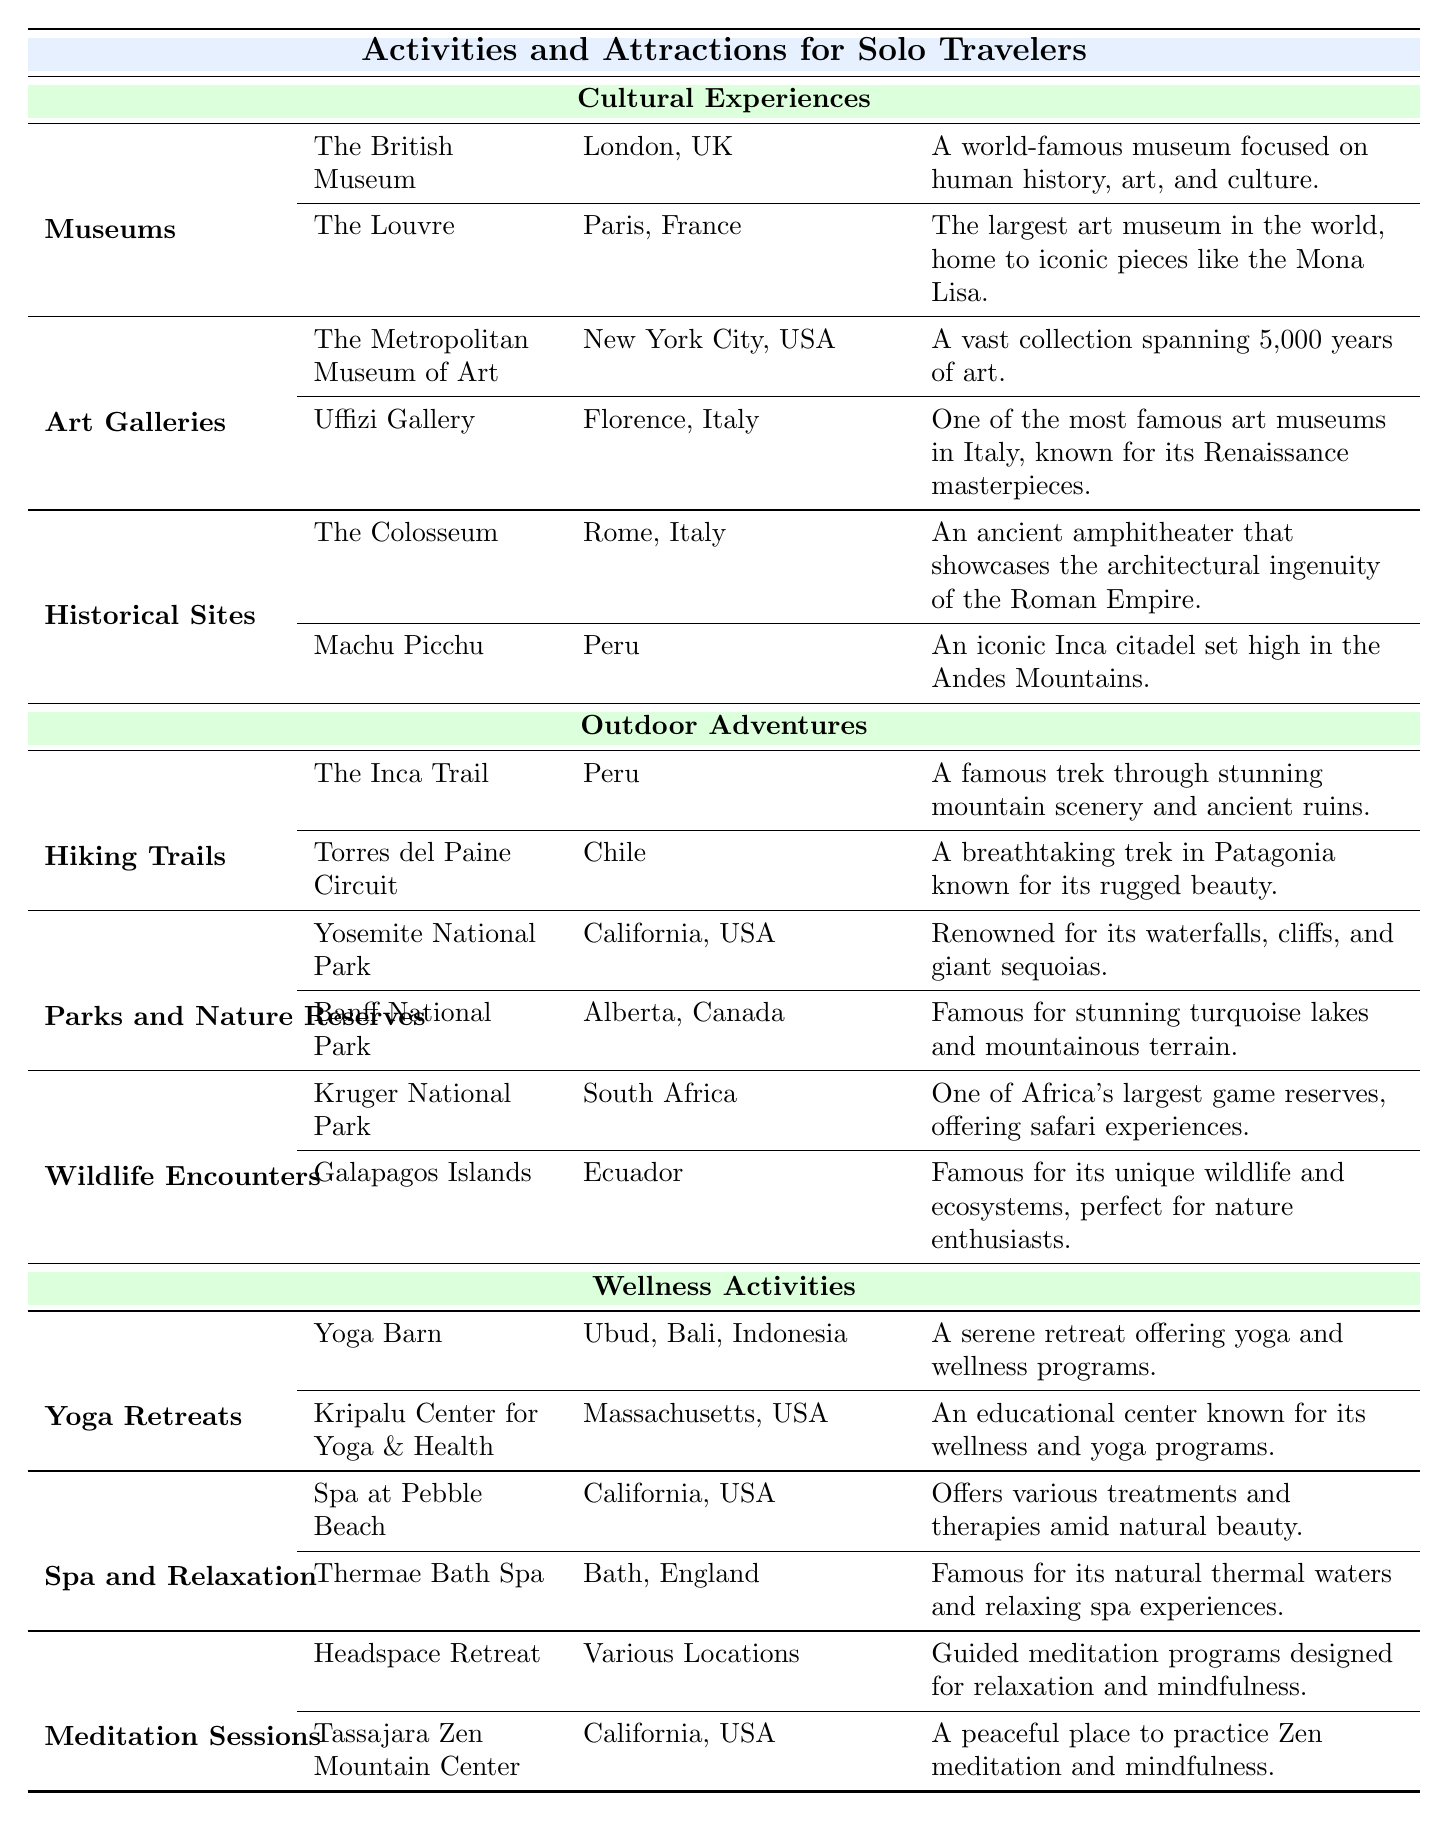What are two museums listed under Cultural Experiences? From the table, under Cultural Experiences, specifically the Museums section, two examples are given: The British Museum located in London, UK, and The Louvre located in Paris, France.
Answer: The British Museum, The Louvre Which country is home to the Galapagos Islands? Looking at the Wildlife Encounters section, the Galapagos Islands are listed with their location noted as Ecuador.
Answer: Ecuador Is the Thermae Bath Spa located in the USA? The table indicates that the Thermae Bath Spa is located in Bath, England, not in the USA, making the statement false.
Answer: No What is the description of the Yoga Barn? The entry for Yoga Barn in the Yoga Retreats section describes it as "A serene retreat offering yoga and wellness programs." This is directly gathered from the description provided in the table.
Answer: A serene retreat offering yoga and wellness programs Which has more outdoor adventure options, Hiking Trails or Parks and Nature Reserves? The Hiking Trails section lists two hiking trails, while the Parks and Nature Reserves section also lists two parks. Since both have the same number of entries, they are equal.
Answer: They have the same number of options What are the two locations for Wellness Activities? From the table, we see three types of wellness activities. The locations include: Ubud, Bali, Indonesia for Yoga Barn and Massachusetts, USA for Kripalu Center for Yoga & Health under Yoga Retreats. The same method applies for Spa and Relaxation in California, USA and Bath, England. So, two locations can be California and Bath.
Answer: California, Bath What type of outdoor adventure can you experience in Patagonia? The Torres del Paine Circuit listed under Hiking Trails in the Outdoor Adventures section is specifically noted as a trek in Patagonia known for its rugged beauty. This directly answers the question about outdoor adventures.
Answer: The Torres del Paine Circuit trek Are Wildlife Encounters part of Cultural Experiences? The Wildlife Encounters section is separate from the Cultural Experiences section according to the organization of the table, confirming that Wildlife Encounters are not included in that category.
Answer: No 